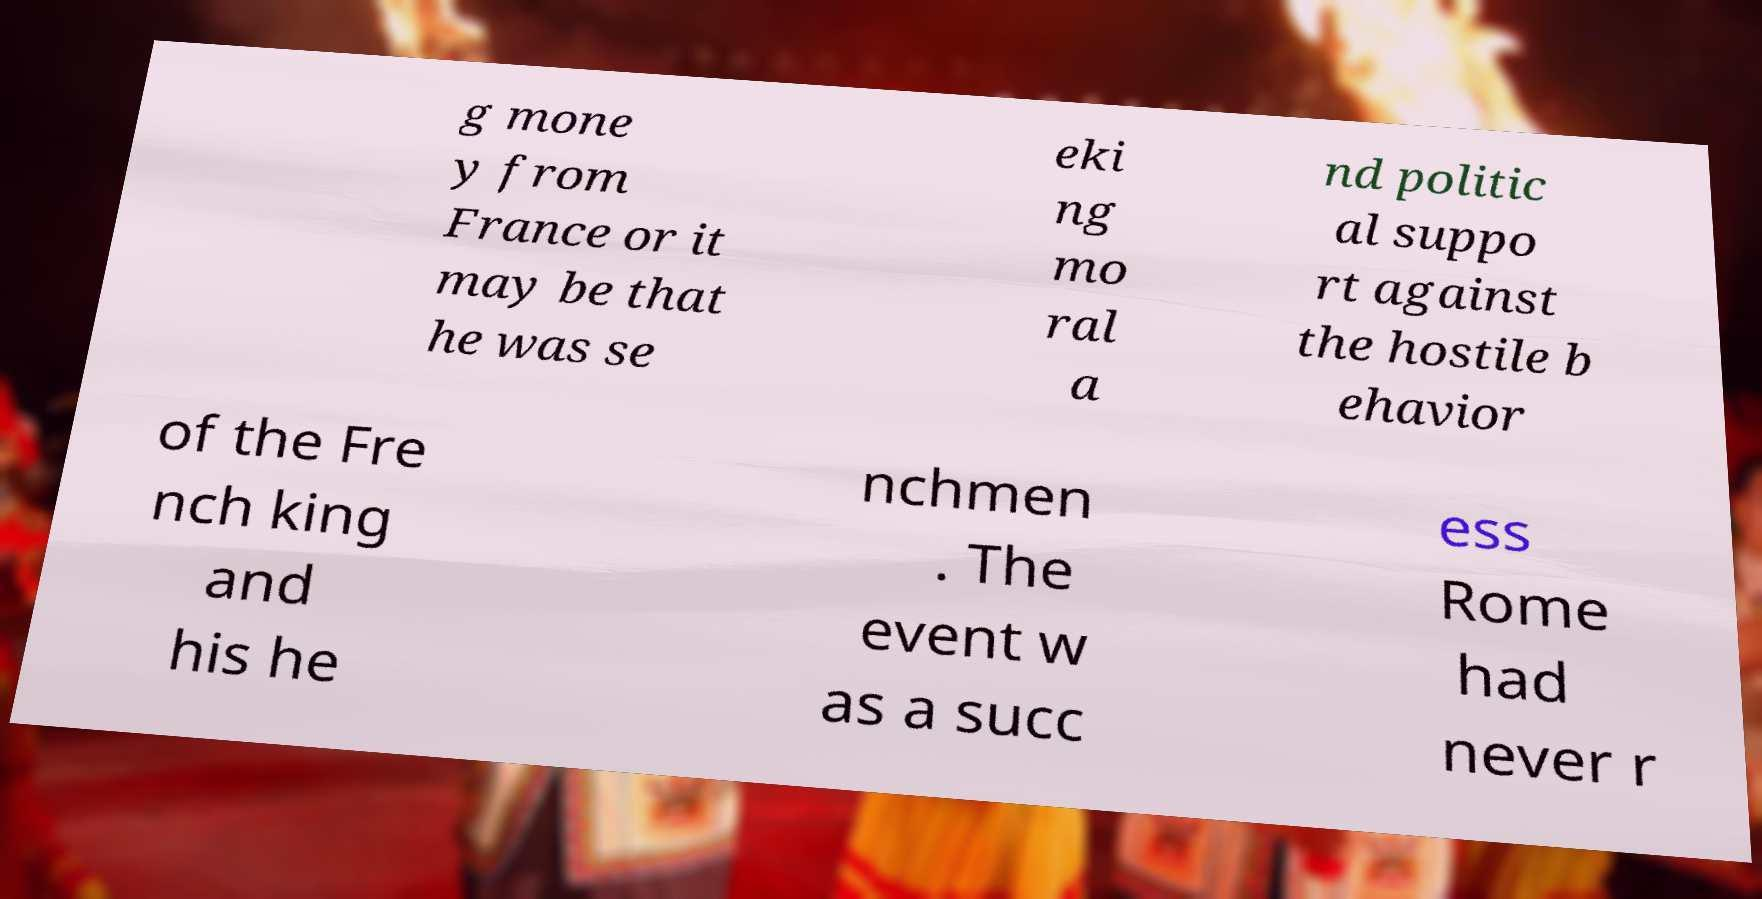What messages or text are displayed in this image? I need them in a readable, typed format. g mone y from France or it may be that he was se eki ng mo ral a nd politic al suppo rt against the hostile b ehavior of the Fre nch king and his he nchmen . The event w as a succ ess Rome had never r 